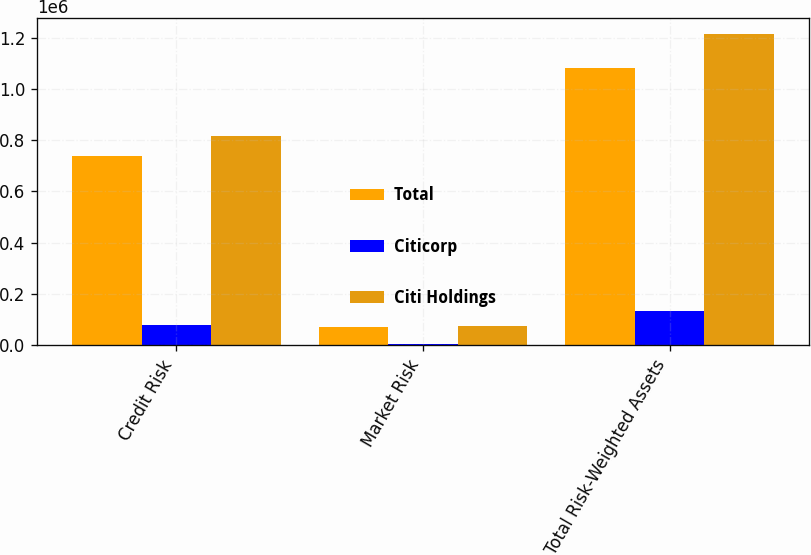Convert chart to OTSL. <chart><loc_0><loc_0><loc_500><loc_500><stacked_bar_chart><ecel><fcel>Credit Risk<fcel>Market Risk<fcel>Total Risk-Weighted Assets<nl><fcel>Total<fcel>736641<fcel>70715<fcel>1.08328e+06<nl><fcel>Citicorp<fcel>79819<fcel>4102<fcel>133000<nl><fcel>Citi Holdings<fcel>816460<fcel>74817<fcel>1.21628e+06<nl></chart> 